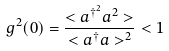Convert formula to latex. <formula><loc_0><loc_0><loc_500><loc_500>g ^ { 2 } ( 0 ) = \frac { < a ^ { \dagger ^ { 2 } } a ^ { 2 } > } { < a ^ { \dagger } a > ^ { 2 } } < 1</formula> 